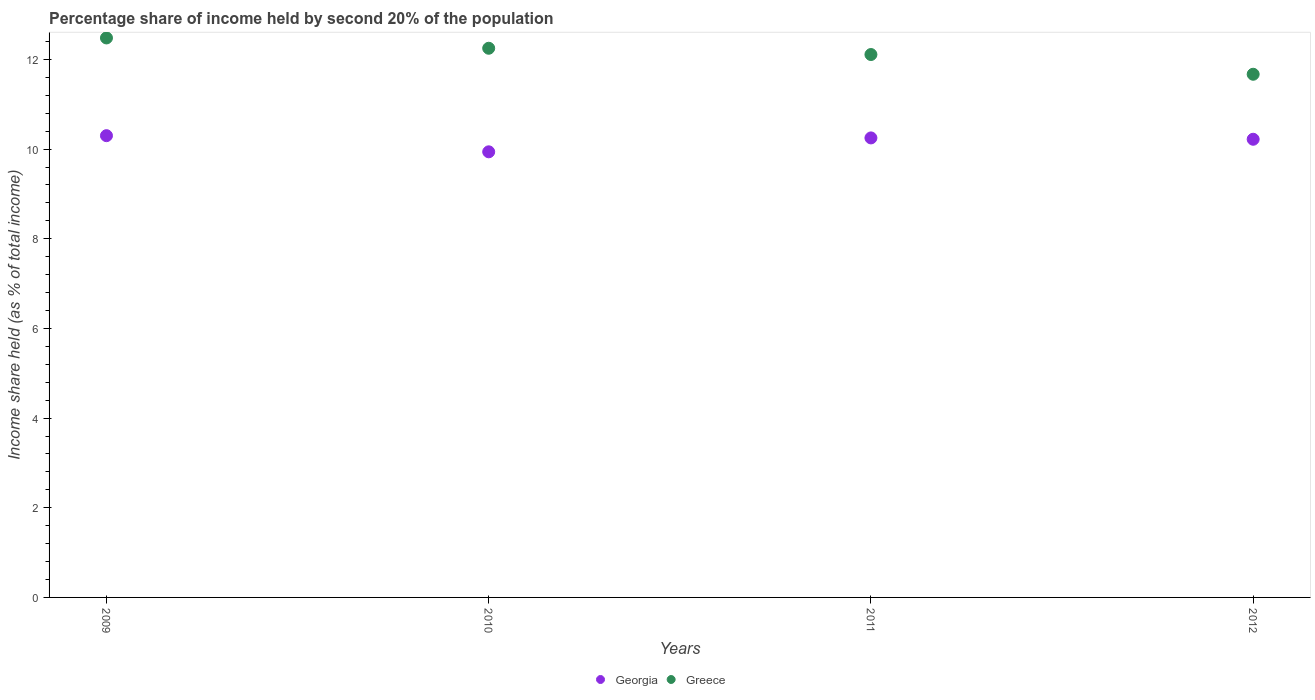Is the number of dotlines equal to the number of legend labels?
Your response must be concise. Yes. What is the share of income held by second 20% of the population in Greece in 2011?
Give a very brief answer. 12.11. Across all years, what is the minimum share of income held by second 20% of the population in Greece?
Provide a short and direct response. 11.67. What is the total share of income held by second 20% of the population in Greece in the graph?
Give a very brief answer. 48.51. What is the difference between the share of income held by second 20% of the population in Georgia in 2009 and that in 2012?
Give a very brief answer. 0.08. What is the difference between the share of income held by second 20% of the population in Georgia in 2011 and the share of income held by second 20% of the population in Greece in 2009?
Provide a succinct answer. -2.23. What is the average share of income held by second 20% of the population in Greece per year?
Make the answer very short. 12.13. In the year 2009, what is the difference between the share of income held by second 20% of the population in Greece and share of income held by second 20% of the population in Georgia?
Provide a short and direct response. 2.18. What is the ratio of the share of income held by second 20% of the population in Georgia in 2010 to that in 2012?
Offer a terse response. 0.97. What is the difference between the highest and the second highest share of income held by second 20% of the population in Greece?
Ensure brevity in your answer.  0.23. What is the difference between the highest and the lowest share of income held by second 20% of the population in Georgia?
Make the answer very short. 0.36. Is the share of income held by second 20% of the population in Georgia strictly less than the share of income held by second 20% of the population in Greece over the years?
Give a very brief answer. Yes. Are the values on the major ticks of Y-axis written in scientific E-notation?
Keep it short and to the point. No. How are the legend labels stacked?
Your response must be concise. Horizontal. What is the title of the graph?
Your answer should be compact. Percentage share of income held by second 20% of the population. What is the label or title of the X-axis?
Provide a succinct answer. Years. What is the label or title of the Y-axis?
Give a very brief answer. Income share held (as % of total income). What is the Income share held (as % of total income) in Greece in 2009?
Your answer should be very brief. 12.48. What is the Income share held (as % of total income) of Georgia in 2010?
Your answer should be compact. 9.94. What is the Income share held (as % of total income) of Greece in 2010?
Give a very brief answer. 12.25. What is the Income share held (as % of total income) in Georgia in 2011?
Your response must be concise. 10.25. What is the Income share held (as % of total income) of Greece in 2011?
Offer a terse response. 12.11. What is the Income share held (as % of total income) in Georgia in 2012?
Your answer should be compact. 10.22. What is the Income share held (as % of total income) of Greece in 2012?
Provide a short and direct response. 11.67. Across all years, what is the maximum Income share held (as % of total income) of Greece?
Keep it short and to the point. 12.48. Across all years, what is the minimum Income share held (as % of total income) in Georgia?
Provide a succinct answer. 9.94. Across all years, what is the minimum Income share held (as % of total income) in Greece?
Give a very brief answer. 11.67. What is the total Income share held (as % of total income) in Georgia in the graph?
Provide a short and direct response. 40.71. What is the total Income share held (as % of total income) of Greece in the graph?
Your response must be concise. 48.51. What is the difference between the Income share held (as % of total income) in Georgia in 2009 and that in 2010?
Your response must be concise. 0.36. What is the difference between the Income share held (as % of total income) of Greece in 2009 and that in 2010?
Provide a succinct answer. 0.23. What is the difference between the Income share held (as % of total income) in Greece in 2009 and that in 2011?
Your answer should be very brief. 0.37. What is the difference between the Income share held (as % of total income) in Georgia in 2009 and that in 2012?
Give a very brief answer. 0.08. What is the difference between the Income share held (as % of total income) of Greece in 2009 and that in 2012?
Offer a terse response. 0.81. What is the difference between the Income share held (as % of total income) of Georgia in 2010 and that in 2011?
Your response must be concise. -0.31. What is the difference between the Income share held (as % of total income) in Greece in 2010 and that in 2011?
Your response must be concise. 0.14. What is the difference between the Income share held (as % of total income) of Georgia in 2010 and that in 2012?
Your answer should be compact. -0.28. What is the difference between the Income share held (as % of total income) of Greece in 2010 and that in 2012?
Keep it short and to the point. 0.58. What is the difference between the Income share held (as % of total income) of Greece in 2011 and that in 2012?
Keep it short and to the point. 0.44. What is the difference between the Income share held (as % of total income) of Georgia in 2009 and the Income share held (as % of total income) of Greece in 2010?
Your response must be concise. -1.95. What is the difference between the Income share held (as % of total income) of Georgia in 2009 and the Income share held (as % of total income) of Greece in 2011?
Your answer should be very brief. -1.81. What is the difference between the Income share held (as % of total income) in Georgia in 2009 and the Income share held (as % of total income) in Greece in 2012?
Keep it short and to the point. -1.37. What is the difference between the Income share held (as % of total income) in Georgia in 2010 and the Income share held (as % of total income) in Greece in 2011?
Give a very brief answer. -2.17. What is the difference between the Income share held (as % of total income) in Georgia in 2010 and the Income share held (as % of total income) in Greece in 2012?
Keep it short and to the point. -1.73. What is the difference between the Income share held (as % of total income) in Georgia in 2011 and the Income share held (as % of total income) in Greece in 2012?
Offer a very short reply. -1.42. What is the average Income share held (as % of total income) of Georgia per year?
Provide a short and direct response. 10.18. What is the average Income share held (as % of total income) of Greece per year?
Provide a succinct answer. 12.13. In the year 2009, what is the difference between the Income share held (as % of total income) of Georgia and Income share held (as % of total income) of Greece?
Your answer should be very brief. -2.18. In the year 2010, what is the difference between the Income share held (as % of total income) of Georgia and Income share held (as % of total income) of Greece?
Give a very brief answer. -2.31. In the year 2011, what is the difference between the Income share held (as % of total income) in Georgia and Income share held (as % of total income) in Greece?
Make the answer very short. -1.86. In the year 2012, what is the difference between the Income share held (as % of total income) of Georgia and Income share held (as % of total income) of Greece?
Your response must be concise. -1.45. What is the ratio of the Income share held (as % of total income) in Georgia in 2009 to that in 2010?
Give a very brief answer. 1.04. What is the ratio of the Income share held (as % of total income) of Greece in 2009 to that in 2010?
Your answer should be very brief. 1.02. What is the ratio of the Income share held (as % of total income) of Georgia in 2009 to that in 2011?
Your answer should be compact. 1. What is the ratio of the Income share held (as % of total income) of Greece in 2009 to that in 2011?
Provide a short and direct response. 1.03. What is the ratio of the Income share held (as % of total income) of Georgia in 2009 to that in 2012?
Your response must be concise. 1.01. What is the ratio of the Income share held (as % of total income) of Greece in 2009 to that in 2012?
Provide a succinct answer. 1.07. What is the ratio of the Income share held (as % of total income) of Georgia in 2010 to that in 2011?
Offer a very short reply. 0.97. What is the ratio of the Income share held (as % of total income) in Greece in 2010 to that in 2011?
Your response must be concise. 1.01. What is the ratio of the Income share held (as % of total income) in Georgia in 2010 to that in 2012?
Offer a terse response. 0.97. What is the ratio of the Income share held (as % of total income) of Greece in 2010 to that in 2012?
Your answer should be very brief. 1.05. What is the ratio of the Income share held (as % of total income) of Georgia in 2011 to that in 2012?
Provide a short and direct response. 1. What is the ratio of the Income share held (as % of total income) in Greece in 2011 to that in 2012?
Offer a terse response. 1.04. What is the difference between the highest and the second highest Income share held (as % of total income) of Georgia?
Make the answer very short. 0.05. What is the difference between the highest and the second highest Income share held (as % of total income) of Greece?
Give a very brief answer. 0.23. What is the difference between the highest and the lowest Income share held (as % of total income) in Georgia?
Offer a terse response. 0.36. What is the difference between the highest and the lowest Income share held (as % of total income) in Greece?
Your response must be concise. 0.81. 